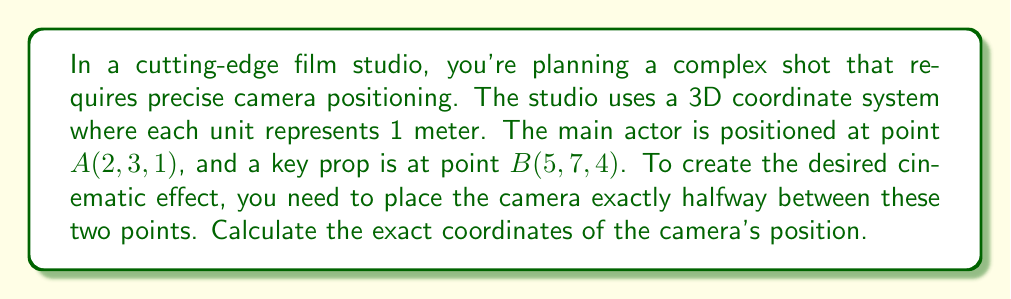Can you answer this question? To solve this problem, we'll follow these steps:

1) First, we need to find the midpoint between points A and B. The midpoint formula in 3D space is:

   $$M = (\frac{x_1 + x_2}{2}, \frac{y_1 + y_2}{2}, \frac{z_1 + z_2}{2})$$

   Where $(x_1, y_1, z_1)$ are the coordinates of point A and $(x_2, y_2, z_2)$ are the coordinates of point B.

2) Let's substitute our values:
   
   A(2, 3, 1) and B(5, 7, 4)

3) Now, let's calculate each coordinate of the midpoint:

   x-coordinate: $\frac{2 + 5}{2} = \frac{7}{2} = 3.5$
   
   y-coordinate: $\frac{3 + 7}{2} = \frac{10}{2} = 5$
   
   z-coordinate: $\frac{1 + 4}{2} = \frac{5}{2} = 2.5$

4) Therefore, the midpoint M, which is where the camera should be positioned, is (3.5, 5, 2.5).

5) To verify this is indeed halfway between A and B, we can calculate the distance from A to M and from M to B using the distance formula in 3D space:

   $$d = \sqrt{(x_2-x_1)^2 + (y_2-y_1)^2 + (z_2-z_1)^2}$$

   Both distances should be equal if M is the midpoint.
Answer: The camera should be positioned at coordinates (3.5, 5, 2.5) in the studio's 3D space. 